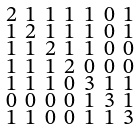<formula> <loc_0><loc_0><loc_500><loc_500>\begin{smallmatrix} 2 & 1 & 1 & 1 & 1 & 0 & 1 \\ 1 & 2 & 1 & 1 & 1 & 0 & 1 \\ 1 & 1 & 2 & 1 & 1 & 0 & 0 \\ 1 & 1 & 1 & 2 & 0 & 0 & 0 \\ 1 & 1 & 1 & 0 & 3 & 1 & 1 \\ 0 & 0 & 0 & 0 & 1 & 3 & 1 \\ 1 & 1 & 0 & 0 & 1 & 1 & 3 \end{smallmatrix}</formula> 